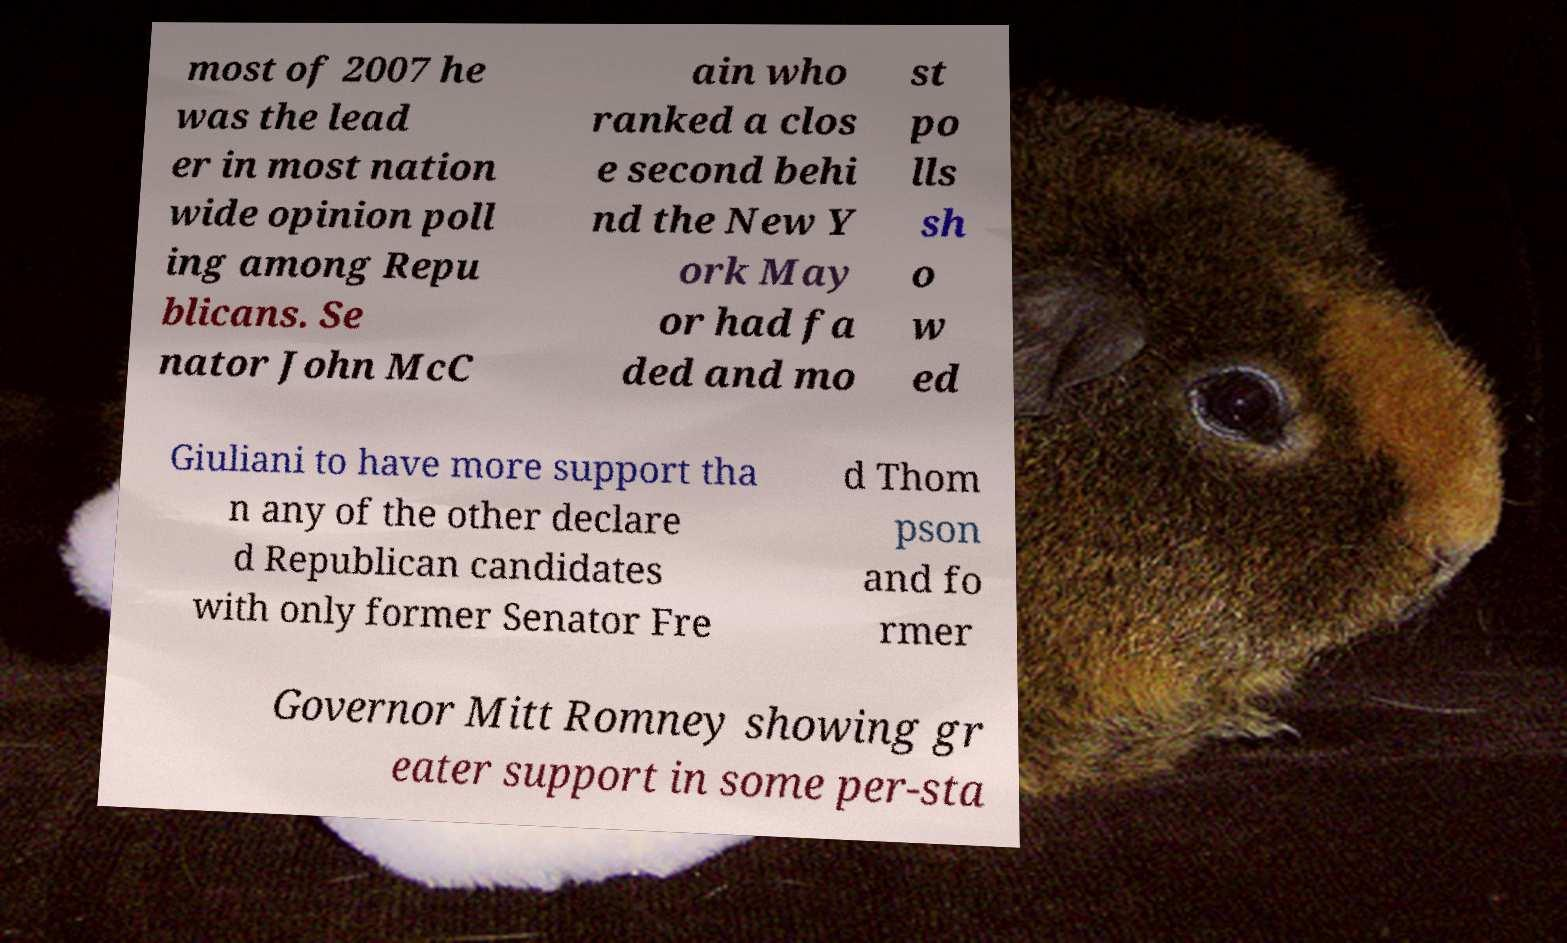For documentation purposes, I need the text within this image transcribed. Could you provide that? most of 2007 he was the lead er in most nation wide opinion poll ing among Repu blicans. Se nator John McC ain who ranked a clos e second behi nd the New Y ork May or had fa ded and mo st po lls sh o w ed Giuliani to have more support tha n any of the other declare d Republican candidates with only former Senator Fre d Thom pson and fo rmer Governor Mitt Romney showing gr eater support in some per-sta 